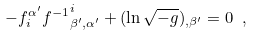Convert formula to latex. <formula><loc_0><loc_0><loc_500><loc_500>- f _ { i } ^ { \alpha ^ { \prime } } f { ^ { - 1 } } _ { \beta ^ { \prime } , \alpha ^ { \prime } } ^ { i } + ( \ln \sqrt { - g } ) _ { , \beta ^ { \prime } } = 0 \ ,</formula> 